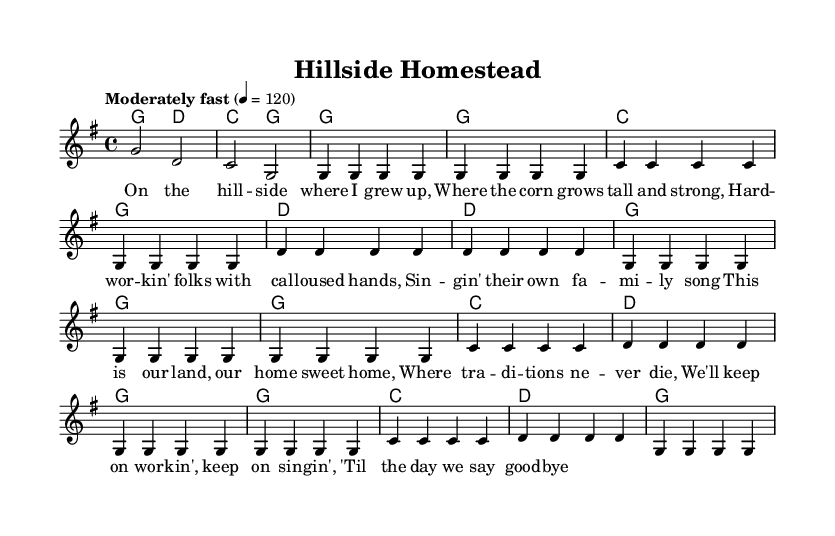What is the key signature of this music? The key signature of the music is G major, which contains one sharp (F#). You can identify this by looking at the key signature indicator at the beginning of the staff.
Answer: G major What is the time signature of this piece? The time signature is 4/4, which is indicated at the beginning of the score. You can tell because it shows four beats per measure and a quarter note receives one beat.
Answer: 4/4 What is the tempo marking in this sheet music? The tempo marking is "Moderately fast" set at 120 beats per minute. This is indicated at the beginning of the score, describing how fast the music should be played.
Answer: Moderately fast How many measures are in the verse? The verse consists of eight measures, as indicated by the grouping of the notes and the bar lines present in the melody section. Counting the segments between bar lines will confirm this.
Answer: 8 What is the main theme of the chorus lyrics? The main theme of the chorus expresses a sense of pride and commitment to home and tradition, indicating the community's values. This is derived from the content of the lyrics, which speak about keeping traditions alive and working together.
Answer: Pride and commitment to home Which instruments are typically featured in a traditional bluegrass arrangement like this? Traditional bluegrass arrangements typically feature instruments such as the banjo, fiddle, mandolin, and acoustic guitar. While the score doesn't explicitly list instruments, these are commonly associated with the genre.
Answer: Banjo, fiddle, mandolin, guitar What is the significance of singing a "family song" in the context of rural life? Singing a "family song" signifies strong familial bonds and the preservation of tradition and identity within a rural community. The lyrics suggest that music plays a vital role in expressing these values, enhancing the community spirit.
Answer: Preservation of tradition and identity 